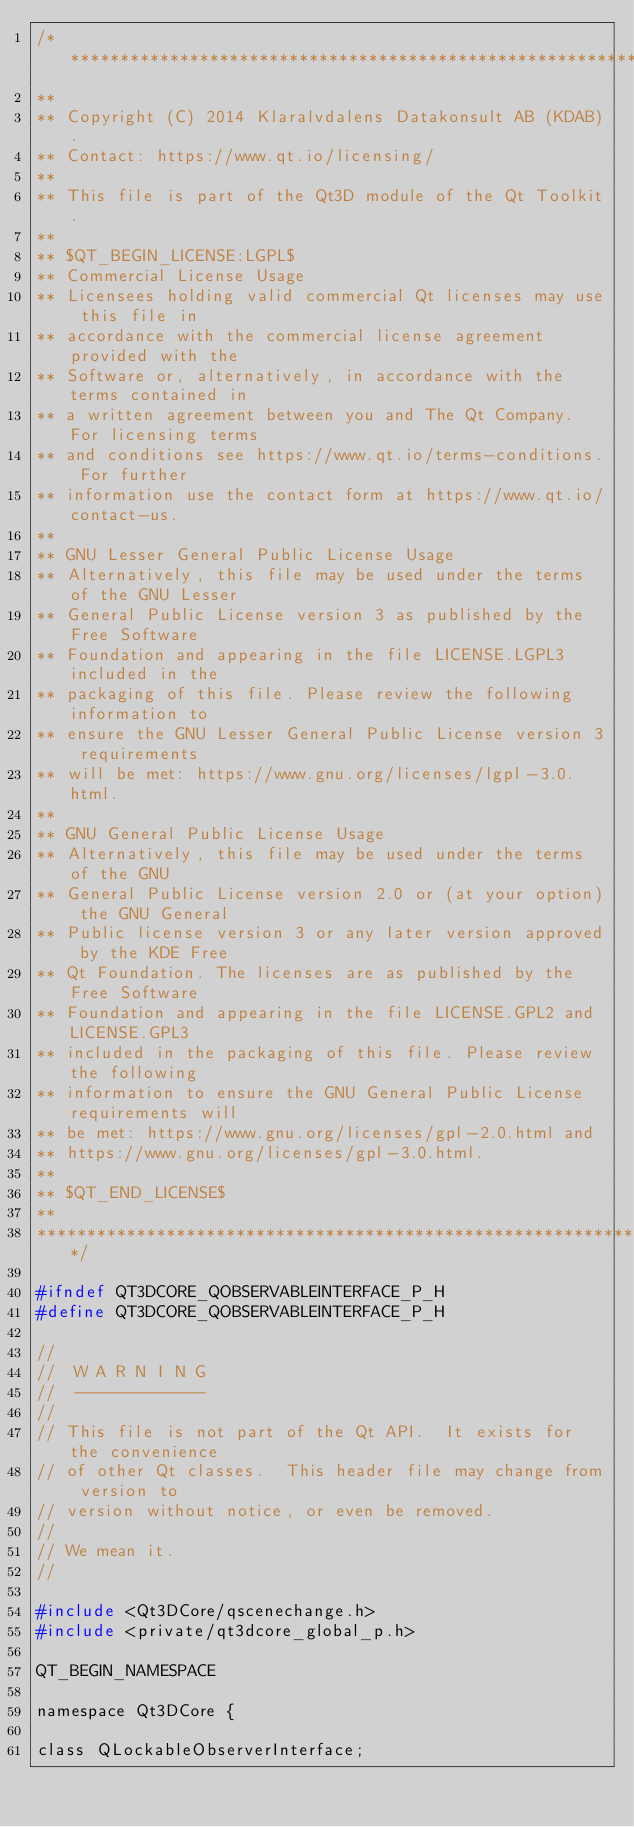<code> <loc_0><loc_0><loc_500><loc_500><_C_>/****************************************************************************
**
** Copyright (C) 2014 Klaralvdalens Datakonsult AB (KDAB).
** Contact: https://www.qt.io/licensing/
**
** This file is part of the Qt3D module of the Qt Toolkit.
**
** $QT_BEGIN_LICENSE:LGPL$
** Commercial License Usage
** Licensees holding valid commercial Qt licenses may use this file in
** accordance with the commercial license agreement provided with the
** Software or, alternatively, in accordance with the terms contained in
** a written agreement between you and The Qt Company. For licensing terms
** and conditions see https://www.qt.io/terms-conditions. For further
** information use the contact form at https://www.qt.io/contact-us.
**
** GNU Lesser General Public License Usage
** Alternatively, this file may be used under the terms of the GNU Lesser
** General Public License version 3 as published by the Free Software
** Foundation and appearing in the file LICENSE.LGPL3 included in the
** packaging of this file. Please review the following information to
** ensure the GNU Lesser General Public License version 3 requirements
** will be met: https://www.gnu.org/licenses/lgpl-3.0.html.
**
** GNU General Public License Usage
** Alternatively, this file may be used under the terms of the GNU
** General Public License version 2.0 or (at your option) the GNU General
** Public license version 3 or any later version approved by the KDE Free
** Qt Foundation. The licenses are as published by the Free Software
** Foundation and appearing in the file LICENSE.GPL2 and LICENSE.GPL3
** included in the packaging of this file. Please review the following
** information to ensure the GNU General Public License requirements will
** be met: https://www.gnu.org/licenses/gpl-2.0.html and
** https://www.gnu.org/licenses/gpl-3.0.html.
**
** $QT_END_LICENSE$
**
****************************************************************************/

#ifndef QT3DCORE_QOBSERVABLEINTERFACE_P_H
#define QT3DCORE_QOBSERVABLEINTERFACE_P_H

//
//  W A R N I N G
//  -------------
//
// This file is not part of the Qt API.  It exists for the convenience
// of other Qt classes.  This header file may change from version to
// version without notice, or even be removed.
//
// We mean it.
//

#include <Qt3DCore/qscenechange.h>
#include <private/qt3dcore_global_p.h>

QT_BEGIN_NAMESPACE

namespace Qt3DCore {

class QLockableObserverInterface;
</code> 